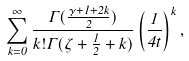Convert formula to latex. <formula><loc_0><loc_0><loc_500><loc_500>\sum _ { k = 0 } ^ { \infty } \frac { \Gamma ( \frac { \gamma + 1 + 2 k } { 2 } ) } { k ! \Gamma ( \zeta + \frac { 1 } { 2 } + k ) } \left ( \frac { 1 } { 4 t } \right ) ^ { k } ,</formula> 